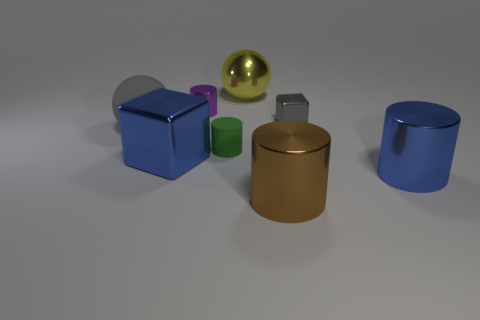There is a big blue object that is in front of the blue shiny cube; what is its shape?
Ensure brevity in your answer.  Cylinder. There is a large matte sphere in front of the large yellow shiny object; does it have the same color as the small shiny cube?
Your answer should be compact. Yes. There is a tiny cube that is the same color as the large rubber object; what material is it?
Ensure brevity in your answer.  Metal. There is a shiny cube to the left of the green rubber cylinder; does it have the same size as the big shiny sphere?
Your answer should be very brief. Yes. Are there any rubber spheres that have the same color as the small metal block?
Your response must be concise. Yes. Is there a cylinder in front of the tiny object that is to the right of the large brown cylinder?
Ensure brevity in your answer.  Yes. Is there a large yellow ball made of the same material as the large gray thing?
Make the answer very short. No. What is the material of the gray thing that is left of the tiny cylinder that is in front of the small gray shiny thing?
Provide a succinct answer. Rubber. What material is the thing that is to the left of the big brown shiny cylinder and on the right side of the green rubber cylinder?
Ensure brevity in your answer.  Metal. Is the number of small green objects behind the purple shiny thing the same as the number of tiny red blocks?
Offer a terse response. Yes. 